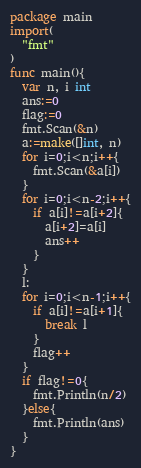Convert code to text. <code><loc_0><loc_0><loc_500><loc_500><_Go_>package main
import(
  "fmt"
)
func main(){
  var n, i int
  ans:=0
  flag:=0
  fmt.Scan(&n)
  a:=make([]int, n)
  for i=0;i<n;i++{
    fmt.Scan(&a[i])
  }
  for i=0;i<n-2;i++{
    if a[i]!=a[i+2]{
      a[i+2]=a[i]
      ans++
    }
  }
  l:
  for i=0;i<n-1;i++{
    if a[i]!=a[i+1]{
      break l
    }
    flag++
  }
  if flag!=0{
    fmt.Println(n/2)
  }else{
    fmt.Println(ans)
  }
}
</code> 